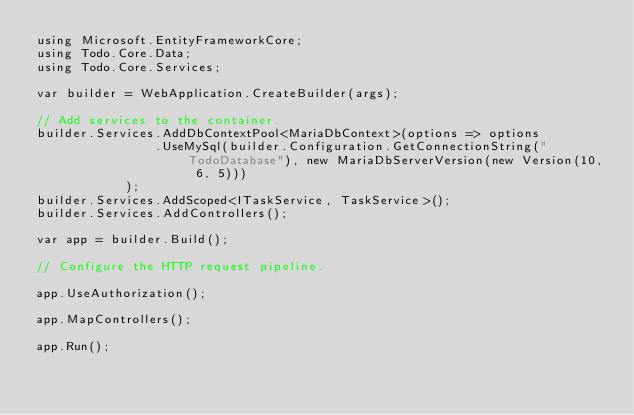<code> <loc_0><loc_0><loc_500><loc_500><_C#_>using Microsoft.EntityFrameworkCore;
using Todo.Core.Data;
using Todo.Core.Services;

var builder = WebApplication.CreateBuilder(args);

// Add services to the container.
builder.Services.AddDbContextPool<MariaDbContext>(options => options
                .UseMySql(builder.Configuration.GetConnectionString("TodoDatabase"), new MariaDbServerVersion(new Version(10, 6, 5)))
            );
builder.Services.AddScoped<ITaskService, TaskService>();
builder.Services.AddControllers();

var app = builder.Build();

// Configure the HTTP request pipeline.

app.UseAuthorization();

app.MapControllers();

app.Run();
</code> 